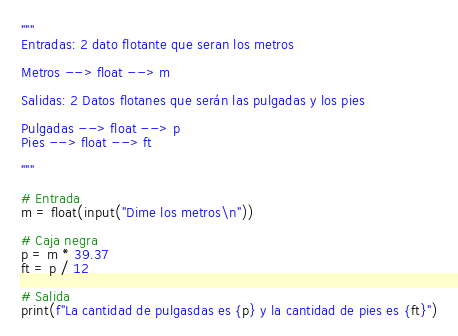<code> <loc_0><loc_0><loc_500><loc_500><_Python_>"""
Entradas: 2 dato flotante que seran los metros 

Metros --> float --> m

Salidas: 2 Datos flotanes que serán las pulgadas y los pies

Pulgadas --> float --> p
Pies --> float --> ft

"""

# Entrada
m = float(input("Dime los metros\n"))

# Caja negra
p = m * 39.37 
ft = p / 12

# Salida
print(f"La cantidad de pulgasdas es {p} y la cantidad de pies es {ft}")
</code> 